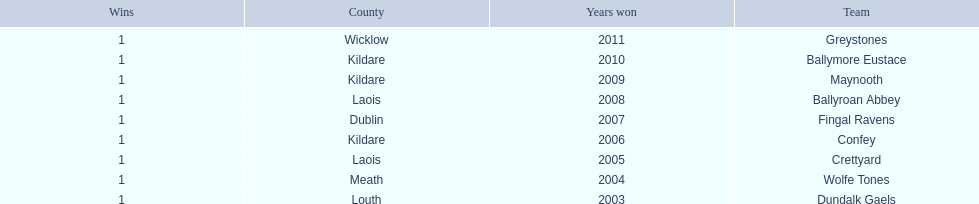What is the total of wins on the chart 9. 